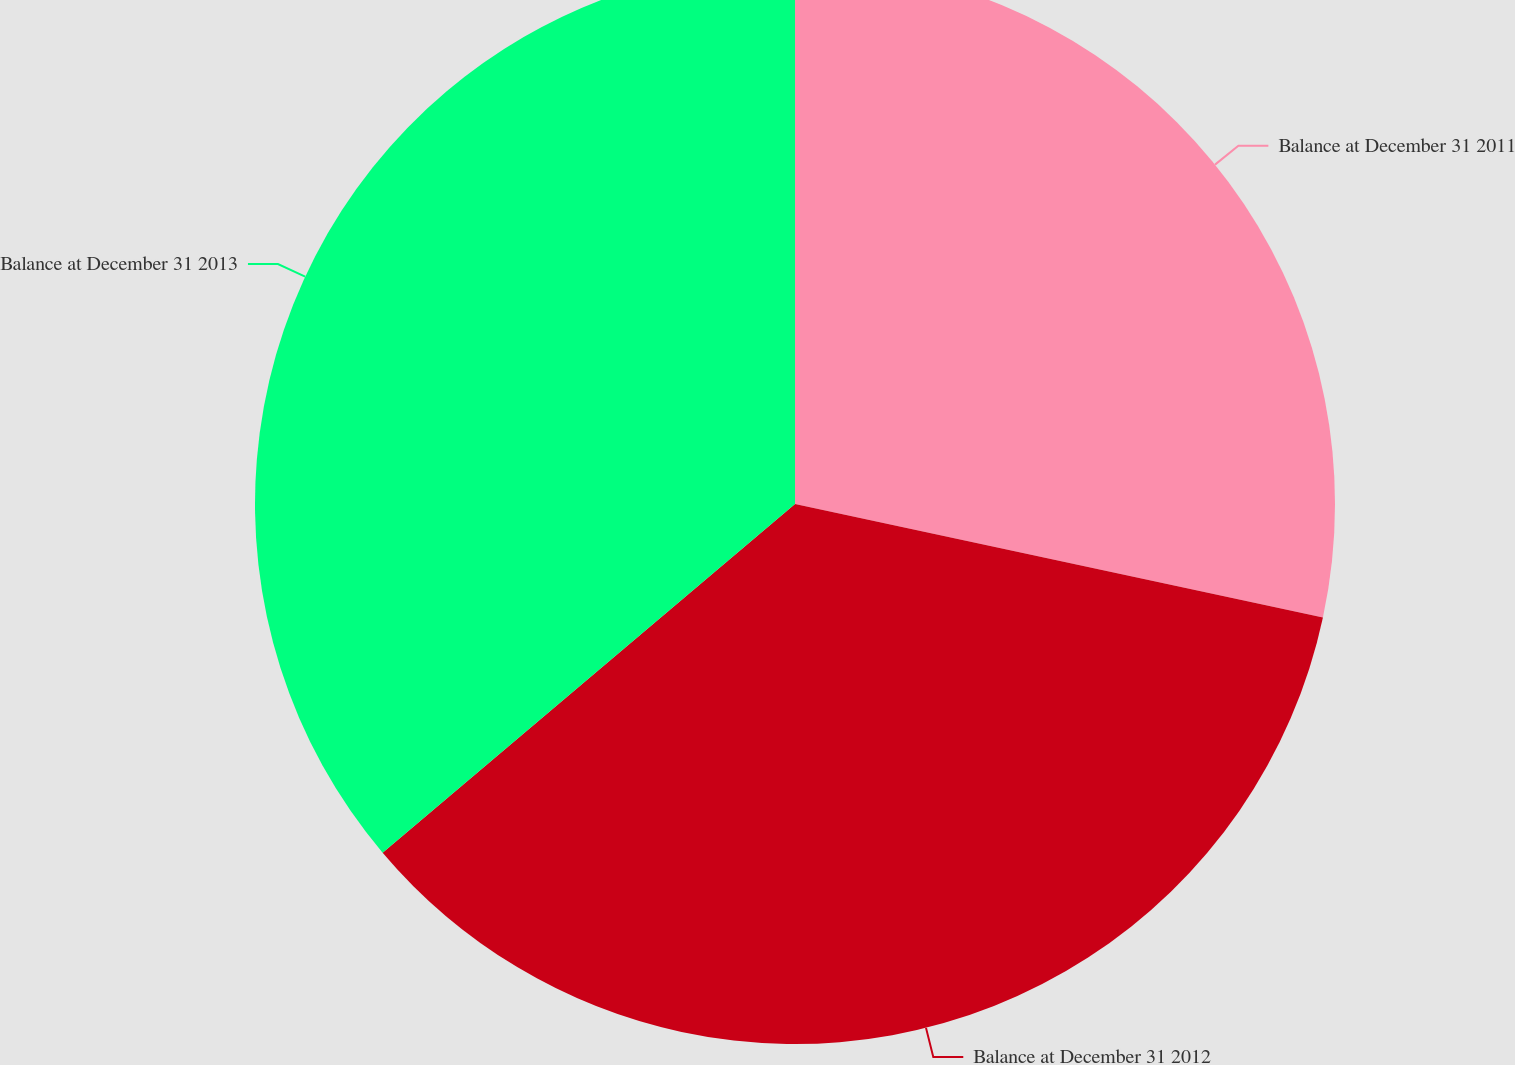<chart> <loc_0><loc_0><loc_500><loc_500><pie_chart><fcel>Balance at December 31 2011<fcel>Balance at December 31 2012<fcel>Balance at December 31 2013<nl><fcel>28.37%<fcel>35.46%<fcel>36.17%<nl></chart> 